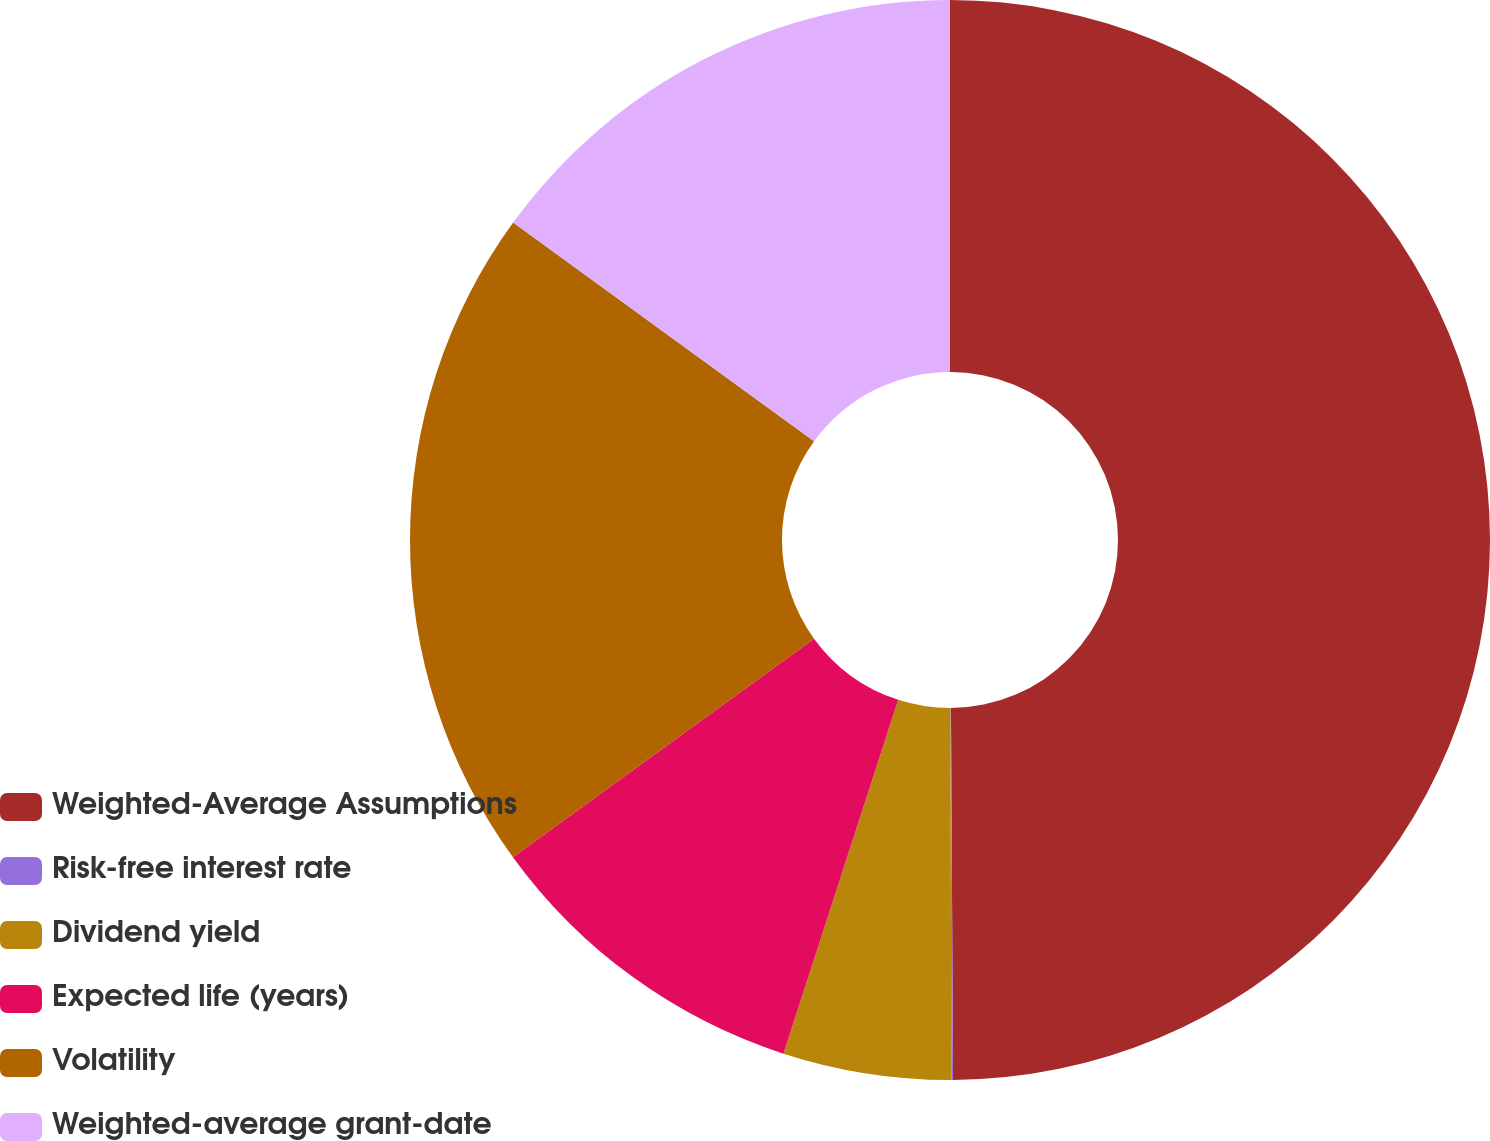Convert chart to OTSL. <chart><loc_0><loc_0><loc_500><loc_500><pie_chart><fcel>Weighted-Average Assumptions<fcel>Risk-free interest rate<fcel>Dividend yield<fcel>Expected life (years)<fcel>Volatility<fcel>Weighted-average grant-date<nl><fcel>49.91%<fcel>0.05%<fcel>5.03%<fcel>10.02%<fcel>19.99%<fcel>15.0%<nl></chart> 